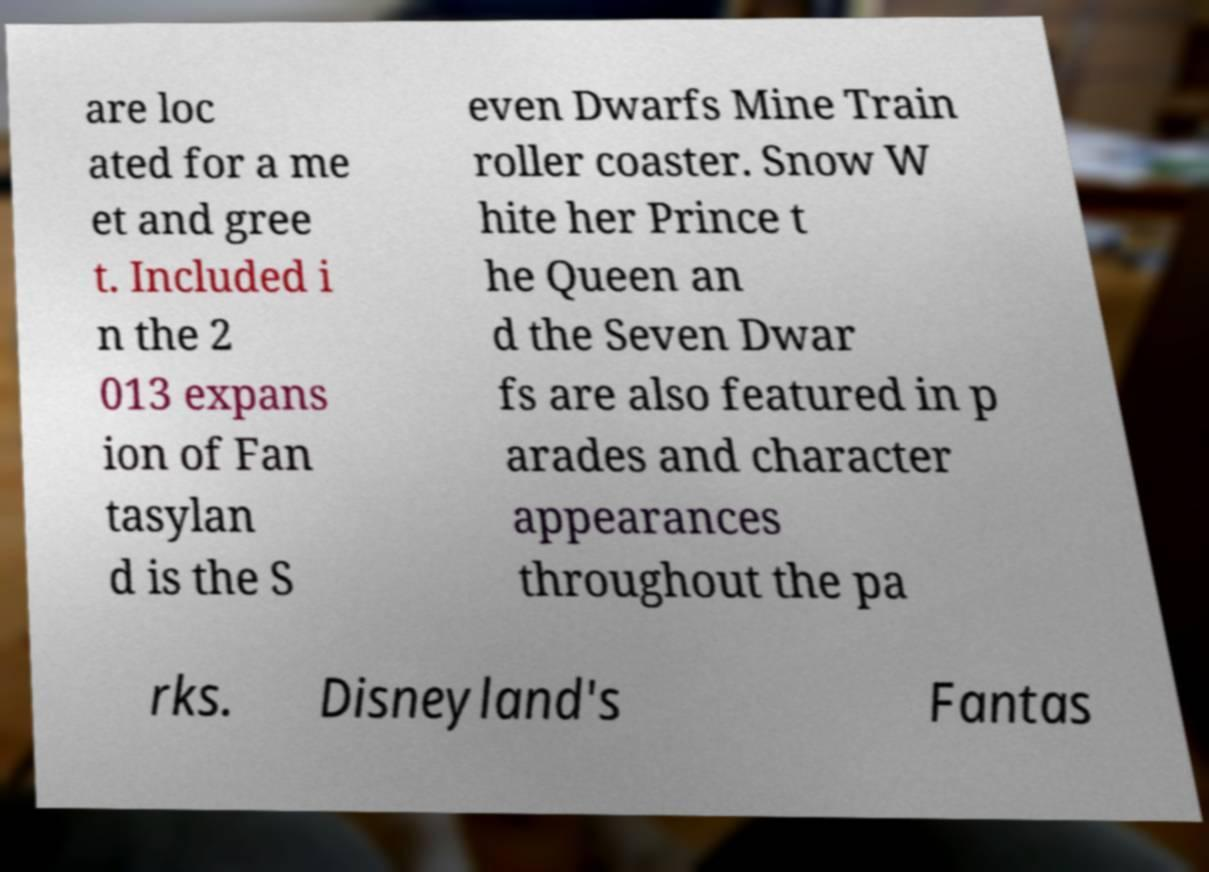What messages or text are displayed in this image? I need them in a readable, typed format. are loc ated for a me et and gree t. Included i n the 2 013 expans ion of Fan tasylan d is the S even Dwarfs Mine Train roller coaster. Snow W hite her Prince t he Queen an d the Seven Dwar fs are also featured in p arades and character appearances throughout the pa rks. Disneyland's Fantas 